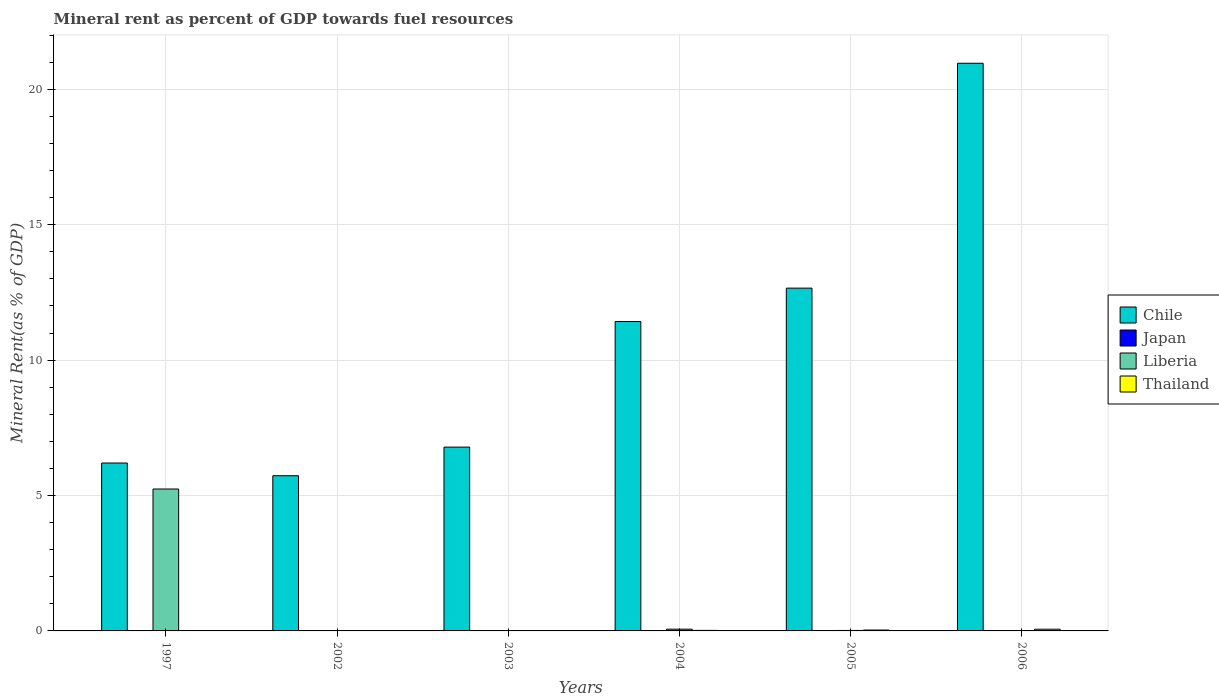How many different coloured bars are there?
Offer a terse response. 4. How many groups of bars are there?
Provide a short and direct response. 6. Are the number of bars per tick equal to the number of legend labels?
Your answer should be compact. Yes. Are the number of bars on each tick of the X-axis equal?
Give a very brief answer. Yes. How many bars are there on the 2nd tick from the right?
Provide a short and direct response. 4. What is the label of the 2nd group of bars from the left?
Your answer should be compact. 2002. What is the mineral rent in Japan in 2004?
Ensure brevity in your answer.  0. Across all years, what is the maximum mineral rent in Japan?
Offer a very short reply. 0. Across all years, what is the minimum mineral rent in Liberia?
Give a very brief answer. 0.01. What is the total mineral rent in Thailand in the graph?
Your answer should be very brief. 0.14. What is the difference between the mineral rent in Chile in 2002 and that in 2004?
Provide a succinct answer. -5.7. What is the difference between the mineral rent in Liberia in 1997 and the mineral rent in Chile in 2002?
Make the answer very short. -0.49. What is the average mineral rent in Thailand per year?
Give a very brief answer. 0.02. In the year 2004, what is the difference between the mineral rent in Chile and mineral rent in Japan?
Your answer should be compact. 11.43. What is the ratio of the mineral rent in Chile in 1997 to that in 2005?
Ensure brevity in your answer.  0.49. Is the mineral rent in Chile in 2003 less than that in 2006?
Provide a succinct answer. Yes. What is the difference between the highest and the second highest mineral rent in Liberia?
Your answer should be compact. 5.18. What is the difference between the highest and the lowest mineral rent in Chile?
Offer a very short reply. 15.23. In how many years, is the mineral rent in Japan greater than the average mineral rent in Japan taken over all years?
Offer a very short reply. 2. Is the sum of the mineral rent in Chile in 2003 and 2005 greater than the maximum mineral rent in Thailand across all years?
Ensure brevity in your answer.  Yes. Is it the case that in every year, the sum of the mineral rent in Liberia and mineral rent in Chile is greater than the sum of mineral rent in Thailand and mineral rent in Japan?
Offer a very short reply. Yes. What does the 1st bar from the right in 2002 represents?
Give a very brief answer. Thailand. How many bars are there?
Keep it short and to the point. 24. Are all the bars in the graph horizontal?
Provide a short and direct response. No. How many years are there in the graph?
Keep it short and to the point. 6. Are the values on the major ticks of Y-axis written in scientific E-notation?
Ensure brevity in your answer.  No. Does the graph contain grids?
Ensure brevity in your answer.  Yes. How are the legend labels stacked?
Keep it short and to the point. Vertical. What is the title of the graph?
Your answer should be very brief. Mineral rent as percent of GDP towards fuel resources. What is the label or title of the Y-axis?
Give a very brief answer. Mineral Rent(as % of GDP). What is the Mineral Rent(as % of GDP) of Chile in 1997?
Provide a succinct answer. 6.2. What is the Mineral Rent(as % of GDP) of Japan in 1997?
Provide a short and direct response. 4.86493891704915e-5. What is the Mineral Rent(as % of GDP) of Liberia in 1997?
Your answer should be very brief. 5.24. What is the Mineral Rent(as % of GDP) of Thailand in 1997?
Offer a terse response. 0.01. What is the Mineral Rent(as % of GDP) in Chile in 2002?
Ensure brevity in your answer.  5.73. What is the Mineral Rent(as % of GDP) of Japan in 2002?
Provide a succinct answer. 0. What is the Mineral Rent(as % of GDP) of Liberia in 2002?
Offer a terse response. 0.01. What is the Mineral Rent(as % of GDP) in Thailand in 2002?
Give a very brief answer. 0.01. What is the Mineral Rent(as % of GDP) in Chile in 2003?
Your answer should be compact. 6.79. What is the Mineral Rent(as % of GDP) of Japan in 2003?
Provide a succinct answer. 0. What is the Mineral Rent(as % of GDP) in Liberia in 2003?
Offer a terse response. 0.01. What is the Mineral Rent(as % of GDP) of Thailand in 2003?
Provide a succinct answer. 0.01. What is the Mineral Rent(as % of GDP) of Chile in 2004?
Your answer should be very brief. 11.43. What is the Mineral Rent(as % of GDP) in Japan in 2004?
Give a very brief answer. 0. What is the Mineral Rent(as % of GDP) in Liberia in 2004?
Your answer should be very brief. 0.06. What is the Mineral Rent(as % of GDP) of Thailand in 2004?
Provide a succinct answer. 0.02. What is the Mineral Rent(as % of GDP) of Chile in 2005?
Your answer should be compact. 12.66. What is the Mineral Rent(as % of GDP) of Japan in 2005?
Keep it short and to the point. 0. What is the Mineral Rent(as % of GDP) in Liberia in 2005?
Your answer should be compact. 0.02. What is the Mineral Rent(as % of GDP) in Thailand in 2005?
Provide a succinct answer. 0.03. What is the Mineral Rent(as % of GDP) of Chile in 2006?
Give a very brief answer. 20.96. What is the Mineral Rent(as % of GDP) of Japan in 2006?
Provide a short and direct response. 0. What is the Mineral Rent(as % of GDP) in Liberia in 2006?
Ensure brevity in your answer.  0.01. What is the Mineral Rent(as % of GDP) in Thailand in 2006?
Keep it short and to the point. 0.06. Across all years, what is the maximum Mineral Rent(as % of GDP) of Chile?
Offer a very short reply. 20.96. Across all years, what is the maximum Mineral Rent(as % of GDP) of Japan?
Keep it short and to the point. 0. Across all years, what is the maximum Mineral Rent(as % of GDP) in Liberia?
Your answer should be very brief. 5.24. Across all years, what is the maximum Mineral Rent(as % of GDP) of Thailand?
Keep it short and to the point. 0.06. Across all years, what is the minimum Mineral Rent(as % of GDP) in Chile?
Give a very brief answer. 5.73. Across all years, what is the minimum Mineral Rent(as % of GDP) of Japan?
Your answer should be compact. 4.86493891704915e-5. Across all years, what is the minimum Mineral Rent(as % of GDP) of Liberia?
Make the answer very short. 0.01. Across all years, what is the minimum Mineral Rent(as % of GDP) in Thailand?
Your answer should be compact. 0.01. What is the total Mineral Rent(as % of GDP) of Chile in the graph?
Offer a terse response. 63.76. What is the total Mineral Rent(as % of GDP) of Japan in the graph?
Make the answer very short. 0. What is the total Mineral Rent(as % of GDP) of Liberia in the graph?
Provide a succinct answer. 5.35. What is the total Mineral Rent(as % of GDP) of Thailand in the graph?
Give a very brief answer. 0.14. What is the difference between the Mineral Rent(as % of GDP) of Chile in 1997 and that in 2002?
Your answer should be compact. 0.47. What is the difference between the Mineral Rent(as % of GDP) of Japan in 1997 and that in 2002?
Provide a succinct answer. -0. What is the difference between the Mineral Rent(as % of GDP) in Liberia in 1997 and that in 2002?
Offer a very short reply. 5.24. What is the difference between the Mineral Rent(as % of GDP) in Thailand in 1997 and that in 2002?
Offer a terse response. -0. What is the difference between the Mineral Rent(as % of GDP) in Chile in 1997 and that in 2003?
Keep it short and to the point. -0.59. What is the difference between the Mineral Rent(as % of GDP) of Japan in 1997 and that in 2003?
Ensure brevity in your answer.  -0. What is the difference between the Mineral Rent(as % of GDP) of Liberia in 1997 and that in 2003?
Your answer should be compact. 5.23. What is the difference between the Mineral Rent(as % of GDP) in Thailand in 1997 and that in 2003?
Provide a short and direct response. -0.01. What is the difference between the Mineral Rent(as % of GDP) of Chile in 1997 and that in 2004?
Provide a succinct answer. -5.23. What is the difference between the Mineral Rent(as % of GDP) of Japan in 1997 and that in 2004?
Offer a very short reply. -0. What is the difference between the Mineral Rent(as % of GDP) of Liberia in 1997 and that in 2004?
Give a very brief answer. 5.18. What is the difference between the Mineral Rent(as % of GDP) in Thailand in 1997 and that in 2004?
Your answer should be very brief. -0.01. What is the difference between the Mineral Rent(as % of GDP) in Chile in 1997 and that in 2005?
Give a very brief answer. -6.46. What is the difference between the Mineral Rent(as % of GDP) of Japan in 1997 and that in 2005?
Ensure brevity in your answer.  -0. What is the difference between the Mineral Rent(as % of GDP) in Liberia in 1997 and that in 2005?
Make the answer very short. 5.22. What is the difference between the Mineral Rent(as % of GDP) of Thailand in 1997 and that in 2005?
Give a very brief answer. -0.03. What is the difference between the Mineral Rent(as % of GDP) in Chile in 1997 and that in 2006?
Your response must be concise. -14.76. What is the difference between the Mineral Rent(as % of GDP) in Japan in 1997 and that in 2006?
Your answer should be compact. -0. What is the difference between the Mineral Rent(as % of GDP) in Liberia in 1997 and that in 2006?
Your response must be concise. 5.23. What is the difference between the Mineral Rent(as % of GDP) of Thailand in 1997 and that in 2006?
Offer a very short reply. -0.06. What is the difference between the Mineral Rent(as % of GDP) of Chile in 2002 and that in 2003?
Keep it short and to the point. -1.06. What is the difference between the Mineral Rent(as % of GDP) in Japan in 2002 and that in 2003?
Your answer should be compact. -0. What is the difference between the Mineral Rent(as % of GDP) in Liberia in 2002 and that in 2003?
Offer a terse response. -0. What is the difference between the Mineral Rent(as % of GDP) of Thailand in 2002 and that in 2003?
Make the answer very short. -0. What is the difference between the Mineral Rent(as % of GDP) of Chile in 2002 and that in 2004?
Keep it short and to the point. -5.7. What is the difference between the Mineral Rent(as % of GDP) in Japan in 2002 and that in 2004?
Give a very brief answer. -0. What is the difference between the Mineral Rent(as % of GDP) of Liberia in 2002 and that in 2004?
Offer a very short reply. -0.06. What is the difference between the Mineral Rent(as % of GDP) in Thailand in 2002 and that in 2004?
Provide a short and direct response. -0.01. What is the difference between the Mineral Rent(as % of GDP) in Chile in 2002 and that in 2005?
Keep it short and to the point. -6.93. What is the difference between the Mineral Rent(as % of GDP) of Japan in 2002 and that in 2005?
Ensure brevity in your answer.  -0. What is the difference between the Mineral Rent(as % of GDP) of Liberia in 2002 and that in 2005?
Your answer should be compact. -0.01. What is the difference between the Mineral Rent(as % of GDP) of Thailand in 2002 and that in 2005?
Offer a very short reply. -0.02. What is the difference between the Mineral Rent(as % of GDP) in Chile in 2002 and that in 2006?
Keep it short and to the point. -15.23. What is the difference between the Mineral Rent(as % of GDP) in Japan in 2002 and that in 2006?
Offer a very short reply. -0. What is the difference between the Mineral Rent(as % of GDP) in Liberia in 2002 and that in 2006?
Offer a terse response. -0.01. What is the difference between the Mineral Rent(as % of GDP) in Thailand in 2002 and that in 2006?
Your response must be concise. -0.05. What is the difference between the Mineral Rent(as % of GDP) in Chile in 2003 and that in 2004?
Your response must be concise. -4.64. What is the difference between the Mineral Rent(as % of GDP) of Japan in 2003 and that in 2004?
Keep it short and to the point. -0. What is the difference between the Mineral Rent(as % of GDP) of Liberia in 2003 and that in 2004?
Offer a very short reply. -0.06. What is the difference between the Mineral Rent(as % of GDP) of Thailand in 2003 and that in 2004?
Give a very brief answer. -0.01. What is the difference between the Mineral Rent(as % of GDP) of Chile in 2003 and that in 2005?
Your response must be concise. -5.87. What is the difference between the Mineral Rent(as % of GDP) in Japan in 2003 and that in 2005?
Make the answer very short. -0. What is the difference between the Mineral Rent(as % of GDP) in Liberia in 2003 and that in 2005?
Offer a very short reply. -0.01. What is the difference between the Mineral Rent(as % of GDP) of Thailand in 2003 and that in 2005?
Keep it short and to the point. -0.02. What is the difference between the Mineral Rent(as % of GDP) in Chile in 2003 and that in 2006?
Your answer should be very brief. -14.17. What is the difference between the Mineral Rent(as % of GDP) of Japan in 2003 and that in 2006?
Provide a succinct answer. -0. What is the difference between the Mineral Rent(as % of GDP) of Liberia in 2003 and that in 2006?
Give a very brief answer. -0. What is the difference between the Mineral Rent(as % of GDP) of Thailand in 2003 and that in 2006?
Provide a short and direct response. -0.05. What is the difference between the Mineral Rent(as % of GDP) of Chile in 2004 and that in 2005?
Make the answer very short. -1.23. What is the difference between the Mineral Rent(as % of GDP) of Japan in 2004 and that in 2005?
Provide a succinct answer. -0. What is the difference between the Mineral Rent(as % of GDP) in Liberia in 2004 and that in 2005?
Offer a terse response. 0.05. What is the difference between the Mineral Rent(as % of GDP) of Thailand in 2004 and that in 2005?
Your answer should be very brief. -0.01. What is the difference between the Mineral Rent(as % of GDP) in Chile in 2004 and that in 2006?
Keep it short and to the point. -9.54. What is the difference between the Mineral Rent(as % of GDP) in Japan in 2004 and that in 2006?
Provide a short and direct response. -0. What is the difference between the Mineral Rent(as % of GDP) in Liberia in 2004 and that in 2006?
Offer a terse response. 0.05. What is the difference between the Mineral Rent(as % of GDP) in Thailand in 2004 and that in 2006?
Make the answer very short. -0.04. What is the difference between the Mineral Rent(as % of GDP) of Chile in 2005 and that in 2006?
Your answer should be very brief. -8.3. What is the difference between the Mineral Rent(as % of GDP) of Japan in 2005 and that in 2006?
Provide a succinct answer. -0. What is the difference between the Mineral Rent(as % of GDP) in Liberia in 2005 and that in 2006?
Make the answer very short. 0.01. What is the difference between the Mineral Rent(as % of GDP) of Thailand in 2005 and that in 2006?
Your answer should be very brief. -0.03. What is the difference between the Mineral Rent(as % of GDP) in Chile in 1997 and the Mineral Rent(as % of GDP) in Japan in 2002?
Your response must be concise. 6.2. What is the difference between the Mineral Rent(as % of GDP) in Chile in 1997 and the Mineral Rent(as % of GDP) in Liberia in 2002?
Your answer should be very brief. 6.2. What is the difference between the Mineral Rent(as % of GDP) of Chile in 1997 and the Mineral Rent(as % of GDP) of Thailand in 2002?
Provide a succinct answer. 6.19. What is the difference between the Mineral Rent(as % of GDP) in Japan in 1997 and the Mineral Rent(as % of GDP) in Liberia in 2002?
Give a very brief answer. -0.01. What is the difference between the Mineral Rent(as % of GDP) of Japan in 1997 and the Mineral Rent(as % of GDP) of Thailand in 2002?
Offer a terse response. -0.01. What is the difference between the Mineral Rent(as % of GDP) in Liberia in 1997 and the Mineral Rent(as % of GDP) in Thailand in 2002?
Your response must be concise. 5.23. What is the difference between the Mineral Rent(as % of GDP) in Chile in 1997 and the Mineral Rent(as % of GDP) in Japan in 2003?
Your response must be concise. 6.2. What is the difference between the Mineral Rent(as % of GDP) of Chile in 1997 and the Mineral Rent(as % of GDP) of Liberia in 2003?
Offer a terse response. 6.19. What is the difference between the Mineral Rent(as % of GDP) of Chile in 1997 and the Mineral Rent(as % of GDP) of Thailand in 2003?
Offer a very short reply. 6.19. What is the difference between the Mineral Rent(as % of GDP) in Japan in 1997 and the Mineral Rent(as % of GDP) in Liberia in 2003?
Your response must be concise. -0.01. What is the difference between the Mineral Rent(as % of GDP) in Japan in 1997 and the Mineral Rent(as % of GDP) in Thailand in 2003?
Keep it short and to the point. -0.01. What is the difference between the Mineral Rent(as % of GDP) of Liberia in 1997 and the Mineral Rent(as % of GDP) of Thailand in 2003?
Ensure brevity in your answer.  5.23. What is the difference between the Mineral Rent(as % of GDP) of Chile in 1997 and the Mineral Rent(as % of GDP) of Japan in 2004?
Keep it short and to the point. 6.2. What is the difference between the Mineral Rent(as % of GDP) in Chile in 1997 and the Mineral Rent(as % of GDP) in Liberia in 2004?
Your answer should be compact. 6.14. What is the difference between the Mineral Rent(as % of GDP) of Chile in 1997 and the Mineral Rent(as % of GDP) of Thailand in 2004?
Make the answer very short. 6.18. What is the difference between the Mineral Rent(as % of GDP) in Japan in 1997 and the Mineral Rent(as % of GDP) in Liberia in 2004?
Your answer should be very brief. -0.06. What is the difference between the Mineral Rent(as % of GDP) in Japan in 1997 and the Mineral Rent(as % of GDP) in Thailand in 2004?
Offer a terse response. -0.02. What is the difference between the Mineral Rent(as % of GDP) of Liberia in 1997 and the Mineral Rent(as % of GDP) of Thailand in 2004?
Provide a short and direct response. 5.22. What is the difference between the Mineral Rent(as % of GDP) in Chile in 1997 and the Mineral Rent(as % of GDP) in Japan in 2005?
Offer a very short reply. 6.2. What is the difference between the Mineral Rent(as % of GDP) in Chile in 1997 and the Mineral Rent(as % of GDP) in Liberia in 2005?
Provide a succinct answer. 6.18. What is the difference between the Mineral Rent(as % of GDP) in Chile in 1997 and the Mineral Rent(as % of GDP) in Thailand in 2005?
Provide a short and direct response. 6.17. What is the difference between the Mineral Rent(as % of GDP) of Japan in 1997 and the Mineral Rent(as % of GDP) of Liberia in 2005?
Keep it short and to the point. -0.02. What is the difference between the Mineral Rent(as % of GDP) of Japan in 1997 and the Mineral Rent(as % of GDP) of Thailand in 2005?
Your answer should be compact. -0.03. What is the difference between the Mineral Rent(as % of GDP) in Liberia in 1997 and the Mineral Rent(as % of GDP) in Thailand in 2005?
Your answer should be compact. 5.21. What is the difference between the Mineral Rent(as % of GDP) in Chile in 1997 and the Mineral Rent(as % of GDP) in Japan in 2006?
Your response must be concise. 6.2. What is the difference between the Mineral Rent(as % of GDP) of Chile in 1997 and the Mineral Rent(as % of GDP) of Liberia in 2006?
Make the answer very short. 6.19. What is the difference between the Mineral Rent(as % of GDP) in Chile in 1997 and the Mineral Rent(as % of GDP) in Thailand in 2006?
Give a very brief answer. 6.14. What is the difference between the Mineral Rent(as % of GDP) in Japan in 1997 and the Mineral Rent(as % of GDP) in Liberia in 2006?
Keep it short and to the point. -0.01. What is the difference between the Mineral Rent(as % of GDP) of Japan in 1997 and the Mineral Rent(as % of GDP) of Thailand in 2006?
Your response must be concise. -0.06. What is the difference between the Mineral Rent(as % of GDP) in Liberia in 1997 and the Mineral Rent(as % of GDP) in Thailand in 2006?
Provide a succinct answer. 5.18. What is the difference between the Mineral Rent(as % of GDP) in Chile in 2002 and the Mineral Rent(as % of GDP) in Japan in 2003?
Provide a succinct answer. 5.73. What is the difference between the Mineral Rent(as % of GDP) in Chile in 2002 and the Mineral Rent(as % of GDP) in Liberia in 2003?
Offer a very short reply. 5.72. What is the difference between the Mineral Rent(as % of GDP) of Chile in 2002 and the Mineral Rent(as % of GDP) of Thailand in 2003?
Offer a terse response. 5.72. What is the difference between the Mineral Rent(as % of GDP) of Japan in 2002 and the Mineral Rent(as % of GDP) of Liberia in 2003?
Your answer should be compact. -0.01. What is the difference between the Mineral Rent(as % of GDP) of Japan in 2002 and the Mineral Rent(as % of GDP) of Thailand in 2003?
Provide a succinct answer. -0.01. What is the difference between the Mineral Rent(as % of GDP) of Liberia in 2002 and the Mineral Rent(as % of GDP) of Thailand in 2003?
Keep it short and to the point. -0.01. What is the difference between the Mineral Rent(as % of GDP) of Chile in 2002 and the Mineral Rent(as % of GDP) of Japan in 2004?
Offer a very short reply. 5.73. What is the difference between the Mineral Rent(as % of GDP) of Chile in 2002 and the Mineral Rent(as % of GDP) of Liberia in 2004?
Give a very brief answer. 5.67. What is the difference between the Mineral Rent(as % of GDP) of Chile in 2002 and the Mineral Rent(as % of GDP) of Thailand in 2004?
Keep it short and to the point. 5.71. What is the difference between the Mineral Rent(as % of GDP) in Japan in 2002 and the Mineral Rent(as % of GDP) in Liberia in 2004?
Offer a terse response. -0.06. What is the difference between the Mineral Rent(as % of GDP) of Japan in 2002 and the Mineral Rent(as % of GDP) of Thailand in 2004?
Keep it short and to the point. -0.02. What is the difference between the Mineral Rent(as % of GDP) of Liberia in 2002 and the Mineral Rent(as % of GDP) of Thailand in 2004?
Your answer should be very brief. -0.01. What is the difference between the Mineral Rent(as % of GDP) of Chile in 2002 and the Mineral Rent(as % of GDP) of Japan in 2005?
Provide a short and direct response. 5.73. What is the difference between the Mineral Rent(as % of GDP) in Chile in 2002 and the Mineral Rent(as % of GDP) in Liberia in 2005?
Keep it short and to the point. 5.71. What is the difference between the Mineral Rent(as % of GDP) of Chile in 2002 and the Mineral Rent(as % of GDP) of Thailand in 2005?
Ensure brevity in your answer.  5.7. What is the difference between the Mineral Rent(as % of GDP) of Japan in 2002 and the Mineral Rent(as % of GDP) of Liberia in 2005?
Keep it short and to the point. -0.02. What is the difference between the Mineral Rent(as % of GDP) in Japan in 2002 and the Mineral Rent(as % of GDP) in Thailand in 2005?
Offer a very short reply. -0.03. What is the difference between the Mineral Rent(as % of GDP) in Liberia in 2002 and the Mineral Rent(as % of GDP) in Thailand in 2005?
Ensure brevity in your answer.  -0.03. What is the difference between the Mineral Rent(as % of GDP) in Chile in 2002 and the Mineral Rent(as % of GDP) in Japan in 2006?
Keep it short and to the point. 5.73. What is the difference between the Mineral Rent(as % of GDP) in Chile in 2002 and the Mineral Rent(as % of GDP) in Liberia in 2006?
Give a very brief answer. 5.72. What is the difference between the Mineral Rent(as % of GDP) of Chile in 2002 and the Mineral Rent(as % of GDP) of Thailand in 2006?
Give a very brief answer. 5.67. What is the difference between the Mineral Rent(as % of GDP) in Japan in 2002 and the Mineral Rent(as % of GDP) in Liberia in 2006?
Your answer should be very brief. -0.01. What is the difference between the Mineral Rent(as % of GDP) of Japan in 2002 and the Mineral Rent(as % of GDP) of Thailand in 2006?
Keep it short and to the point. -0.06. What is the difference between the Mineral Rent(as % of GDP) in Liberia in 2002 and the Mineral Rent(as % of GDP) in Thailand in 2006?
Ensure brevity in your answer.  -0.06. What is the difference between the Mineral Rent(as % of GDP) of Chile in 2003 and the Mineral Rent(as % of GDP) of Japan in 2004?
Offer a terse response. 6.79. What is the difference between the Mineral Rent(as % of GDP) of Chile in 2003 and the Mineral Rent(as % of GDP) of Liberia in 2004?
Ensure brevity in your answer.  6.72. What is the difference between the Mineral Rent(as % of GDP) in Chile in 2003 and the Mineral Rent(as % of GDP) in Thailand in 2004?
Keep it short and to the point. 6.77. What is the difference between the Mineral Rent(as % of GDP) in Japan in 2003 and the Mineral Rent(as % of GDP) in Liberia in 2004?
Offer a terse response. -0.06. What is the difference between the Mineral Rent(as % of GDP) in Japan in 2003 and the Mineral Rent(as % of GDP) in Thailand in 2004?
Ensure brevity in your answer.  -0.02. What is the difference between the Mineral Rent(as % of GDP) in Liberia in 2003 and the Mineral Rent(as % of GDP) in Thailand in 2004?
Offer a very short reply. -0.01. What is the difference between the Mineral Rent(as % of GDP) in Chile in 2003 and the Mineral Rent(as % of GDP) in Japan in 2005?
Provide a short and direct response. 6.79. What is the difference between the Mineral Rent(as % of GDP) of Chile in 2003 and the Mineral Rent(as % of GDP) of Liberia in 2005?
Ensure brevity in your answer.  6.77. What is the difference between the Mineral Rent(as % of GDP) of Chile in 2003 and the Mineral Rent(as % of GDP) of Thailand in 2005?
Your answer should be compact. 6.75. What is the difference between the Mineral Rent(as % of GDP) in Japan in 2003 and the Mineral Rent(as % of GDP) in Liberia in 2005?
Your response must be concise. -0.02. What is the difference between the Mineral Rent(as % of GDP) of Japan in 2003 and the Mineral Rent(as % of GDP) of Thailand in 2005?
Provide a succinct answer. -0.03. What is the difference between the Mineral Rent(as % of GDP) of Liberia in 2003 and the Mineral Rent(as % of GDP) of Thailand in 2005?
Your response must be concise. -0.02. What is the difference between the Mineral Rent(as % of GDP) in Chile in 2003 and the Mineral Rent(as % of GDP) in Japan in 2006?
Offer a very short reply. 6.79. What is the difference between the Mineral Rent(as % of GDP) in Chile in 2003 and the Mineral Rent(as % of GDP) in Liberia in 2006?
Keep it short and to the point. 6.78. What is the difference between the Mineral Rent(as % of GDP) of Chile in 2003 and the Mineral Rent(as % of GDP) of Thailand in 2006?
Ensure brevity in your answer.  6.72. What is the difference between the Mineral Rent(as % of GDP) of Japan in 2003 and the Mineral Rent(as % of GDP) of Liberia in 2006?
Provide a short and direct response. -0.01. What is the difference between the Mineral Rent(as % of GDP) of Japan in 2003 and the Mineral Rent(as % of GDP) of Thailand in 2006?
Provide a short and direct response. -0.06. What is the difference between the Mineral Rent(as % of GDP) of Liberia in 2003 and the Mineral Rent(as % of GDP) of Thailand in 2006?
Ensure brevity in your answer.  -0.05. What is the difference between the Mineral Rent(as % of GDP) of Chile in 2004 and the Mineral Rent(as % of GDP) of Japan in 2005?
Provide a succinct answer. 11.43. What is the difference between the Mineral Rent(as % of GDP) in Chile in 2004 and the Mineral Rent(as % of GDP) in Liberia in 2005?
Offer a very short reply. 11.41. What is the difference between the Mineral Rent(as % of GDP) in Chile in 2004 and the Mineral Rent(as % of GDP) in Thailand in 2005?
Your answer should be compact. 11.39. What is the difference between the Mineral Rent(as % of GDP) in Japan in 2004 and the Mineral Rent(as % of GDP) in Liberia in 2005?
Make the answer very short. -0.02. What is the difference between the Mineral Rent(as % of GDP) in Japan in 2004 and the Mineral Rent(as % of GDP) in Thailand in 2005?
Provide a succinct answer. -0.03. What is the difference between the Mineral Rent(as % of GDP) in Liberia in 2004 and the Mineral Rent(as % of GDP) in Thailand in 2005?
Provide a short and direct response. 0.03. What is the difference between the Mineral Rent(as % of GDP) of Chile in 2004 and the Mineral Rent(as % of GDP) of Japan in 2006?
Your response must be concise. 11.42. What is the difference between the Mineral Rent(as % of GDP) of Chile in 2004 and the Mineral Rent(as % of GDP) of Liberia in 2006?
Make the answer very short. 11.41. What is the difference between the Mineral Rent(as % of GDP) of Chile in 2004 and the Mineral Rent(as % of GDP) of Thailand in 2006?
Give a very brief answer. 11.36. What is the difference between the Mineral Rent(as % of GDP) of Japan in 2004 and the Mineral Rent(as % of GDP) of Liberia in 2006?
Keep it short and to the point. -0.01. What is the difference between the Mineral Rent(as % of GDP) of Japan in 2004 and the Mineral Rent(as % of GDP) of Thailand in 2006?
Your answer should be very brief. -0.06. What is the difference between the Mineral Rent(as % of GDP) in Liberia in 2004 and the Mineral Rent(as % of GDP) in Thailand in 2006?
Provide a succinct answer. 0. What is the difference between the Mineral Rent(as % of GDP) of Chile in 2005 and the Mineral Rent(as % of GDP) of Japan in 2006?
Ensure brevity in your answer.  12.66. What is the difference between the Mineral Rent(as % of GDP) of Chile in 2005 and the Mineral Rent(as % of GDP) of Liberia in 2006?
Keep it short and to the point. 12.65. What is the difference between the Mineral Rent(as % of GDP) of Chile in 2005 and the Mineral Rent(as % of GDP) of Thailand in 2006?
Provide a short and direct response. 12.59. What is the difference between the Mineral Rent(as % of GDP) of Japan in 2005 and the Mineral Rent(as % of GDP) of Liberia in 2006?
Make the answer very short. -0.01. What is the difference between the Mineral Rent(as % of GDP) in Japan in 2005 and the Mineral Rent(as % of GDP) in Thailand in 2006?
Your response must be concise. -0.06. What is the difference between the Mineral Rent(as % of GDP) of Liberia in 2005 and the Mineral Rent(as % of GDP) of Thailand in 2006?
Keep it short and to the point. -0.05. What is the average Mineral Rent(as % of GDP) of Chile per year?
Your response must be concise. 10.63. What is the average Mineral Rent(as % of GDP) in Japan per year?
Ensure brevity in your answer.  0. What is the average Mineral Rent(as % of GDP) in Liberia per year?
Keep it short and to the point. 0.89. What is the average Mineral Rent(as % of GDP) of Thailand per year?
Offer a terse response. 0.02. In the year 1997, what is the difference between the Mineral Rent(as % of GDP) of Chile and Mineral Rent(as % of GDP) of Japan?
Offer a terse response. 6.2. In the year 1997, what is the difference between the Mineral Rent(as % of GDP) of Chile and Mineral Rent(as % of GDP) of Liberia?
Provide a short and direct response. 0.96. In the year 1997, what is the difference between the Mineral Rent(as % of GDP) in Chile and Mineral Rent(as % of GDP) in Thailand?
Ensure brevity in your answer.  6.19. In the year 1997, what is the difference between the Mineral Rent(as % of GDP) in Japan and Mineral Rent(as % of GDP) in Liberia?
Offer a very short reply. -5.24. In the year 1997, what is the difference between the Mineral Rent(as % of GDP) of Japan and Mineral Rent(as % of GDP) of Thailand?
Your answer should be very brief. -0.01. In the year 1997, what is the difference between the Mineral Rent(as % of GDP) in Liberia and Mineral Rent(as % of GDP) in Thailand?
Offer a terse response. 5.23. In the year 2002, what is the difference between the Mineral Rent(as % of GDP) of Chile and Mineral Rent(as % of GDP) of Japan?
Provide a succinct answer. 5.73. In the year 2002, what is the difference between the Mineral Rent(as % of GDP) in Chile and Mineral Rent(as % of GDP) in Liberia?
Offer a very short reply. 5.73. In the year 2002, what is the difference between the Mineral Rent(as % of GDP) of Chile and Mineral Rent(as % of GDP) of Thailand?
Offer a very short reply. 5.72. In the year 2002, what is the difference between the Mineral Rent(as % of GDP) in Japan and Mineral Rent(as % of GDP) in Liberia?
Give a very brief answer. -0.01. In the year 2002, what is the difference between the Mineral Rent(as % of GDP) in Japan and Mineral Rent(as % of GDP) in Thailand?
Offer a very short reply. -0.01. In the year 2002, what is the difference between the Mineral Rent(as % of GDP) of Liberia and Mineral Rent(as % of GDP) of Thailand?
Your answer should be very brief. -0.01. In the year 2003, what is the difference between the Mineral Rent(as % of GDP) in Chile and Mineral Rent(as % of GDP) in Japan?
Your answer should be compact. 6.79. In the year 2003, what is the difference between the Mineral Rent(as % of GDP) of Chile and Mineral Rent(as % of GDP) of Liberia?
Provide a short and direct response. 6.78. In the year 2003, what is the difference between the Mineral Rent(as % of GDP) of Chile and Mineral Rent(as % of GDP) of Thailand?
Your answer should be compact. 6.78. In the year 2003, what is the difference between the Mineral Rent(as % of GDP) in Japan and Mineral Rent(as % of GDP) in Liberia?
Keep it short and to the point. -0.01. In the year 2003, what is the difference between the Mineral Rent(as % of GDP) of Japan and Mineral Rent(as % of GDP) of Thailand?
Your answer should be compact. -0.01. In the year 2003, what is the difference between the Mineral Rent(as % of GDP) of Liberia and Mineral Rent(as % of GDP) of Thailand?
Your response must be concise. -0. In the year 2004, what is the difference between the Mineral Rent(as % of GDP) in Chile and Mineral Rent(as % of GDP) in Japan?
Keep it short and to the point. 11.43. In the year 2004, what is the difference between the Mineral Rent(as % of GDP) of Chile and Mineral Rent(as % of GDP) of Liberia?
Offer a very short reply. 11.36. In the year 2004, what is the difference between the Mineral Rent(as % of GDP) in Chile and Mineral Rent(as % of GDP) in Thailand?
Keep it short and to the point. 11.41. In the year 2004, what is the difference between the Mineral Rent(as % of GDP) of Japan and Mineral Rent(as % of GDP) of Liberia?
Ensure brevity in your answer.  -0.06. In the year 2004, what is the difference between the Mineral Rent(as % of GDP) of Japan and Mineral Rent(as % of GDP) of Thailand?
Offer a terse response. -0.02. In the year 2004, what is the difference between the Mineral Rent(as % of GDP) of Liberia and Mineral Rent(as % of GDP) of Thailand?
Your answer should be compact. 0.05. In the year 2005, what is the difference between the Mineral Rent(as % of GDP) in Chile and Mineral Rent(as % of GDP) in Japan?
Provide a short and direct response. 12.66. In the year 2005, what is the difference between the Mineral Rent(as % of GDP) of Chile and Mineral Rent(as % of GDP) of Liberia?
Keep it short and to the point. 12.64. In the year 2005, what is the difference between the Mineral Rent(as % of GDP) in Chile and Mineral Rent(as % of GDP) in Thailand?
Offer a terse response. 12.63. In the year 2005, what is the difference between the Mineral Rent(as % of GDP) in Japan and Mineral Rent(as % of GDP) in Liberia?
Give a very brief answer. -0.02. In the year 2005, what is the difference between the Mineral Rent(as % of GDP) of Japan and Mineral Rent(as % of GDP) of Thailand?
Ensure brevity in your answer.  -0.03. In the year 2005, what is the difference between the Mineral Rent(as % of GDP) in Liberia and Mineral Rent(as % of GDP) in Thailand?
Make the answer very short. -0.01. In the year 2006, what is the difference between the Mineral Rent(as % of GDP) in Chile and Mineral Rent(as % of GDP) in Japan?
Offer a terse response. 20.96. In the year 2006, what is the difference between the Mineral Rent(as % of GDP) in Chile and Mineral Rent(as % of GDP) in Liberia?
Keep it short and to the point. 20.95. In the year 2006, what is the difference between the Mineral Rent(as % of GDP) of Chile and Mineral Rent(as % of GDP) of Thailand?
Offer a terse response. 20.9. In the year 2006, what is the difference between the Mineral Rent(as % of GDP) in Japan and Mineral Rent(as % of GDP) in Liberia?
Your answer should be compact. -0.01. In the year 2006, what is the difference between the Mineral Rent(as % of GDP) of Japan and Mineral Rent(as % of GDP) of Thailand?
Offer a very short reply. -0.06. In the year 2006, what is the difference between the Mineral Rent(as % of GDP) in Liberia and Mineral Rent(as % of GDP) in Thailand?
Ensure brevity in your answer.  -0.05. What is the ratio of the Mineral Rent(as % of GDP) in Chile in 1997 to that in 2002?
Offer a very short reply. 1.08. What is the ratio of the Mineral Rent(as % of GDP) in Japan in 1997 to that in 2002?
Offer a terse response. 0.31. What is the ratio of the Mineral Rent(as % of GDP) in Liberia in 1997 to that in 2002?
Offer a very short reply. 960.46. What is the ratio of the Mineral Rent(as % of GDP) of Thailand in 1997 to that in 2002?
Ensure brevity in your answer.  0.55. What is the ratio of the Mineral Rent(as % of GDP) of Chile in 1997 to that in 2003?
Your answer should be compact. 0.91. What is the ratio of the Mineral Rent(as % of GDP) of Japan in 1997 to that in 2003?
Your response must be concise. 0.13. What is the ratio of the Mineral Rent(as % of GDP) in Liberia in 1997 to that in 2003?
Provide a short and direct response. 553.67. What is the ratio of the Mineral Rent(as % of GDP) in Thailand in 1997 to that in 2003?
Your answer should be compact. 0.49. What is the ratio of the Mineral Rent(as % of GDP) of Chile in 1997 to that in 2004?
Make the answer very short. 0.54. What is the ratio of the Mineral Rent(as % of GDP) in Japan in 1997 to that in 2004?
Keep it short and to the point. 0.09. What is the ratio of the Mineral Rent(as % of GDP) in Liberia in 1997 to that in 2004?
Your answer should be compact. 81.12. What is the ratio of the Mineral Rent(as % of GDP) in Thailand in 1997 to that in 2004?
Offer a very short reply. 0.3. What is the ratio of the Mineral Rent(as % of GDP) of Chile in 1997 to that in 2005?
Your answer should be compact. 0.49. What is the ratio of the Mineral Rent(as % of GDP) of Japan in 1997 to that in 2005?
Ensure brevity in your answer.  0.07. What is the ratio of the Mineral Rent(as % of GDP) in Liberia in 1997 to that in 2005?
Your answer should be compact. 295.5. What is the ratio of the Mineral Rent(as % of GDP) in Thailand in 1997 to that in 2005?
Provide a succinct answer. 0.18. What is the ratio of the Mineral Rent(as % of GDP) of Chile in 1997 to that in 2006?
Provide a succinct answer. 0.3. What is the ratio of the Mineral Rent(as % of GDP) of Japan in 1997 to that in 2006?
Your answer should be very brief. 0.02. What is the ratio of the Mineral Rent(as % of GDP) of Liberia in 1997 to that in 2006?
Ensure brevity in your answer.  417.93. What is the ratio of the Mineral Rent(as % of GDP) of Thailand in 1997 to that in 2006?
Your answer should be very brief. 0.09. What is the ratio of the Mineral Rent(as % of GDP) of Chile in 2002 to that in 2003?
Provide a succinct answer. 0.84. What is the ratio of the Mineral Rent(as % of GDP) of Japan in 2002 to that in 2003?
Offer a very short reply. 0.42. What is the ratio of the Mineral Rent(as % of GDP) in Liberia in 2002 to that in 2003?
Make the answer very short. 0.58. What is the ratio of the Mineral Rent(as % of GDP) of Thailand in 2002 to that in 2003?
Your answer should be compact. 0.9. What is the ratio of the Mineral Rent(as % of GDP) of Chile in 2002 to that in 2004?
Offer a very short reply. 0.5. What is the ratio of the Mineral Rent(as % of GDP) of Japan in 2002 to that in 2004?
Keep it short and to the point. 0.3. What is the ratio of the Mineral Rent(as % of GDP) of Liberia in 2002 to that in 2004?
Your response must be concise. 0.08. What is the ratio of the Mineral Rent(as % of GDP) in Thailand in 2002 to that in 2004?
Provide a short and direct response. 0.56. What is the ratio of the Mineral Rent(as % of GDP) of Chile in 2002 to that in 2005?
Ensure brevity in your answer.  0.45. What is the ratio of the Mineral Rent(as % of GDP) in Japan in 2002 to that in 2005?
Provide a short and direct response. 0.22. What is the ratio of the Mineral Rent(as % of GDP) in Liberia in 2002 to that in 2005?
Offer a very short reply. 0.31. What is the ratio of the Mineral Rent(as % of GDP) in Thailand in 2002 to that in 2005?
Your answer should be compact. 0.33. What is the ratio of the Mineral Rent(as % of GDP) of Chile in 2002 to that in 2006?
Your response must be concise. 0.27. What is the ratio of the Mineral Rent(as % of GDP) in Japan in 2002 to that in 2006?
Your response must be concise. 0.08. What is the ratio of the Mineral Rent(as % of GDP) in Liberia in 2002 to that in 2006?
Your response must be concise. 0.44. What is the ratio of the Mineral Rent(as % of GDP) in Thailand in 2002 to that in 2006?
Your answer should be compact. 0.17. What is the ratio of the Mineral Rent(as % of GDP) of Chile in 2003 to that in 2004?
Offer a very short reply. 0.59. What is the ratio of the Mineral Rent(as % of GDP) in Japan in 2003 to that in 2004?
Your answer should be compact. 0.71. What is the ratio of the Mineral Rent(as % of GDP) in Liberia in 2003 to that in 2004?
Your answer should be very brief. 0.15. What is the ratio of the Mineral Rent(as % of GDP) in Thailand in 2003 to that in 2004?
Make the answer very short. 0.62. What is the ratio of the Mineral Rent(as % of GDP) in Chile in 2003 to that in 2005?
Your answer should be compact. 0.54. What is the ratio of the Mineral Rent(as % of GDP) in Japan in 2003 to that in 2005?
Provide a succinct answer. 0.53. What is the ratio of the Mineral Rent(as % of GDP) of Liberia in 2003 to that in 2005?
Make the answer very short. 0.53. What is the ratio of the Mineral Rent(as % of GDP) in Thailand in 2003 to that in 2005?
Make the answer very short. 0.37. What is the ratio of the Mineral Rent(as % of GDP) in Chile in 2003 to that in 2006?
Your response must be concise. 0.32. What is the ratio of the Mineral Rent(as % of GDP) in Japan in 2003 to that in 2006?
Your answer should be very brief. 0.18. What is the ratio of the Mineral Rent(as % of GDP) in Liberia in 2003 to that in 2006?
Offer a very short reply. 0.75. What is the ratio of the Mineral Rent(as % of GDP) in Thailand in 2003 to that in 2006?
Keep it short and to the point. 0.19. What is the ratio of the Mineral Rent(as % of GDP) of Chile in 2004 to that in 2005?
Provide a short and direct response. 0.9. What is the ratio of the Mineral Rent(as % of GDP) of Japan in 2004 to that in 2005?
Your answer should be very brief. 0.75. What is the ratio of the Mineral Rent(as % of GDP) in Liberia in 2004 to that in 2005?
Ensure brevity in your answer.  3.64. What is the ratio of the Mineral Rent(as % of GDP) of Thailand in 2004 to that in 2005?
Your response must be concise. 0.6. What is the ratio of the Mineral Rent(as % of GDP) of Chile in 2004 to that in 2006?
Offer a very short reply. 0.55. What is the ratio of the Mineral Rent(as % of GDP) in Japan in 2004 to that in 2006?
Ensure brevity in your answer.  0.25. What is the ratio of the Mineral Rent(as % of GDP) in Liberia in 2004 to that in 2006?
Your answer should be compact. 5.15. What is the ratio of the Mineral Rent(as % of GDP) of Thailand in 2004 to that in 2006?
Offer a terse response. 0.31. What is the ratio of the Mineral Rent(as % of GDP) in Chile in 2005 to that in 2006?
Provide a succinct answer. 0.6. What is the ratio of the Mineral Rent(as % of GDP) of Japan in 2005 to that in 2006?
Provide a short and direct response. 0.34. What is the ratio of the Mineral Rent(as % of GDP) in Liberia in 2005 to that in 2006?
Offer a terse response. 1.41. What is the ratio of the Mineral Rent(as % of GDP) in Thailand in 2005 to that in 2006?
Give a very brief answer. 0.52. What is the difference between the highest and the second highest Mineral Rent(as % of GDP) of Chile?
Give a very brief answer. 8.3. What is the difference between the highest and the second highest Mineral Rent(as % of GDP) of Japan?
Give a very brief answer. 0. What is the difference between the highest and the second highest Mineral Rent(as % of GDP) in Liberia?
Make the answer very short. 5.18. What is the difference between the highest and the second highest Mineral Rent(as % of GDP) in Thailand?
Offer a terse response. 0.03. What is the difference between the highest and the lowest Mineral Rent(as % of GDP) of Chile?
Offer a terse response. 15.23. What is the difference between the highest and the lowest Mineral Rent(as % of GDP) of Japan?
Your answer should be very brief. 0. What is the difference between the highest and the lowest Mineral Rent(as % of GDP) of Liberia?
Your answer should be compact. 5.24. What is the difference between the highest and the lowest Mineral Rent(as % of GDP) in Thailand?
Offer a very short reply. 0.06. 